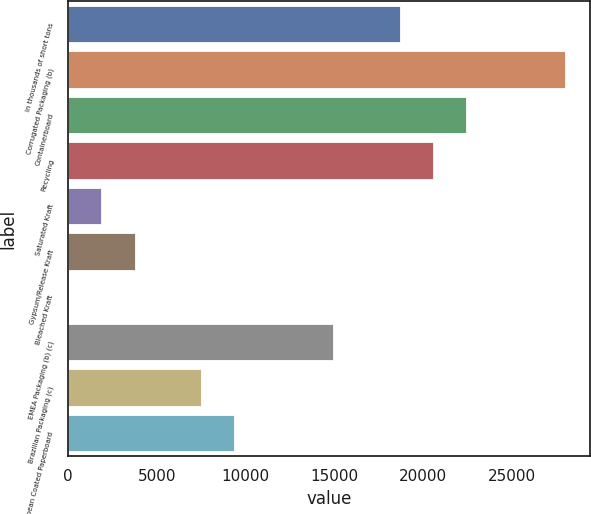Convert chart. <chart><loc_0><loc_0><loc_500><loc_500><bar_chart><fcel>In thousands of short tons<fcel>Corrugated Packaging (b)<fcel>Containerboard<fcel>Recycling<fcel>Saturated Kraft<fcel>Gypsum/Release Kraft<fcel>Bleached Kraft<fcel>EMEA Packaging (b) (c)<fcel>Brazilian Packaging (c)<fcel>European Coated Paperboard<nl><fcel>18674<fcel>27997.5<fcel>22403.4<fcel>20538.7<fcel>1891.7<fcel>3756.4<fcel>27<fcel>14944.6<fcel>7485.8<fcel>9350.5<nl></chart> 